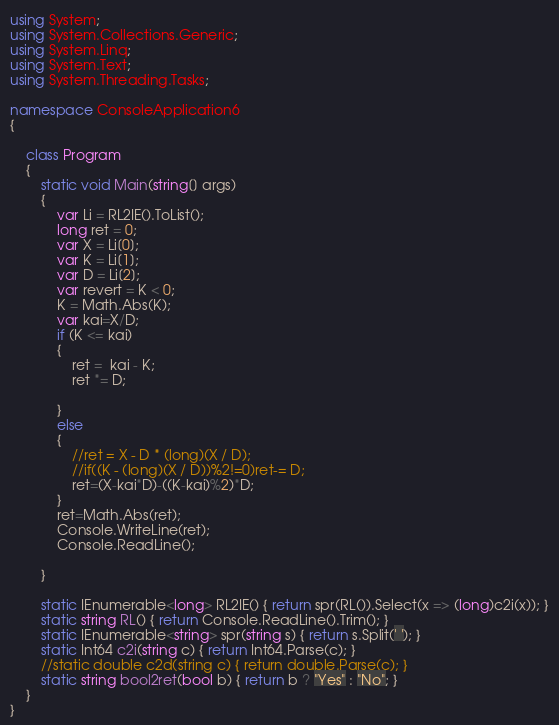<code> <loc_0><loc_0><loc_500><loc_500><_C#_>using System;
using System.Collections.Generic;
using System.Linq;
using System.Text;
using System.Threading.Tasks;

namespace ConsoleApplication6
{

    class Program
    {
        static void Main(string[] args)
        {
            var Li = RL2IE().ToList();
            long ret = 0;
            var X = Li[0];
            var K = Li[1];
            var D = Li[2];
            var revert = K < 0;
            K = Math.Abs(K);
            var kai=X/D;
            if (K <= kai)
            {
                ret =  kai - K;
                ret *= D;
                
            }
            else
            {
                //ret = X - D * (long)(X / D);
                //if((K - (long)(X / D))%2!=0)ret-= D;
                ret=(X-kai*D)-((K-kai)%2)*D;
            }
            ret=Math.Abs(ret);
            Console.WriteLine(ret);
            Console.ReadLine();

        }

        static IEnumerable<long> RL2IE() { return spr(RL()).Select(x => (long)c2i(x)); }
        static string RL() { return Console.ReadLine().Trim(); }
        static IEnumerable<string> spr(string s) { return s.Split(' '); }
        static Int64 c2i(string c) { return Int64.Parse(c); }
        //static double c2d(string c) { return double.Parse(c); }
        static string bool2ret(bool b) { return b ? "Yes" : "No"; }
    }
}
</code> 